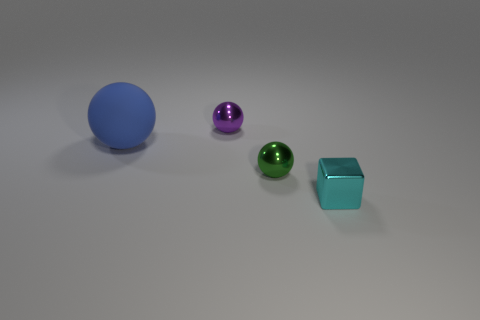Subtract all spheres. How many objects are left? 1 Subtract 3 spheres. How many spheres are left? 0 Subtract all brown blocks. Subtract all brown cylinders. How many blocks are left? 1 Subtract all red cylinders. How many purple spheres are left? 1 Subtract all green shiny things. Subtract all cyan metal objects. How many objects are left? 2 Add 3 green metal spheres. How many green metal spheres are left? 4 Add 2 small green metal spheres. How many small green metal spheres exist? 3 Add 2 small cyan things. How many objects exist? 6 Subtract all metallic spheres. How many spheres are left? 1 Subtract 0 gray balls. How many objects are left? 4 